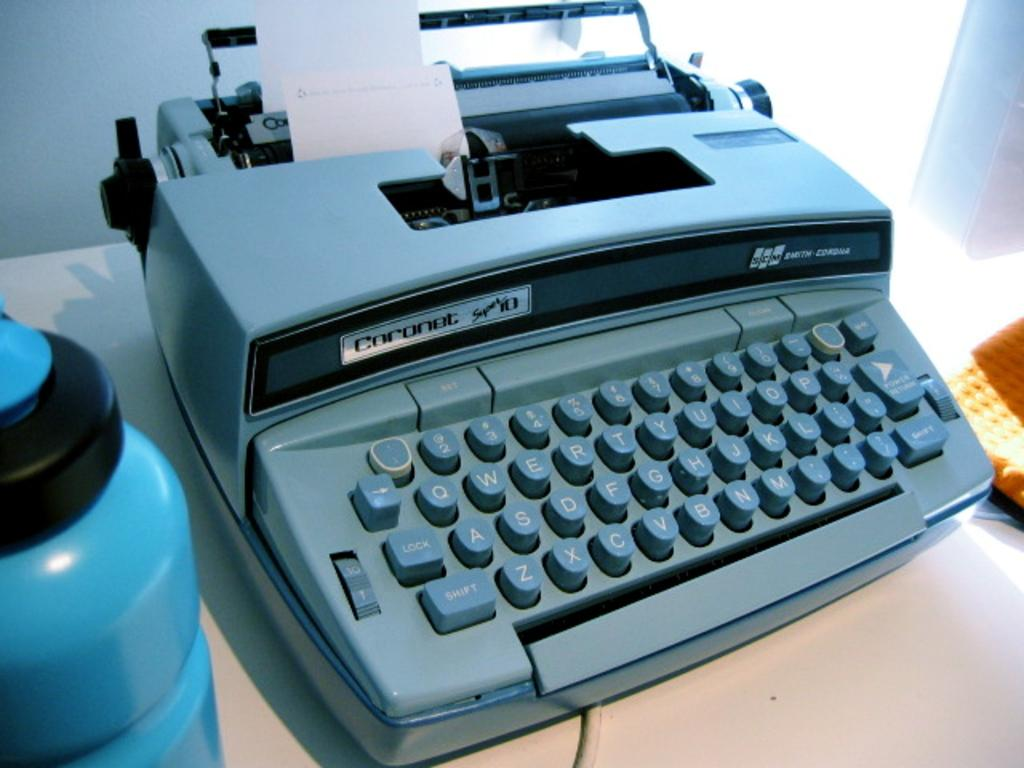Provide a one-sentence caption for the provided image. A blue Coronet typewriter loaded with a small strip of paper is on a flat surface. 